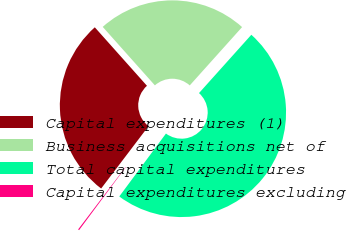Convert chart to OTSL. <chart><loc_0><loc_0><loc_500><loc_500><pie_chart><fcel>Capital expenditures (1)<fcel>Business acquisitions net of<fcel>Total capital expenditures<fcel>Capital expenditures excluding<nl><fcel>28.07%<fcel>23.23%<fcel>48.52%<fcel>0.18%<nl></chart> 